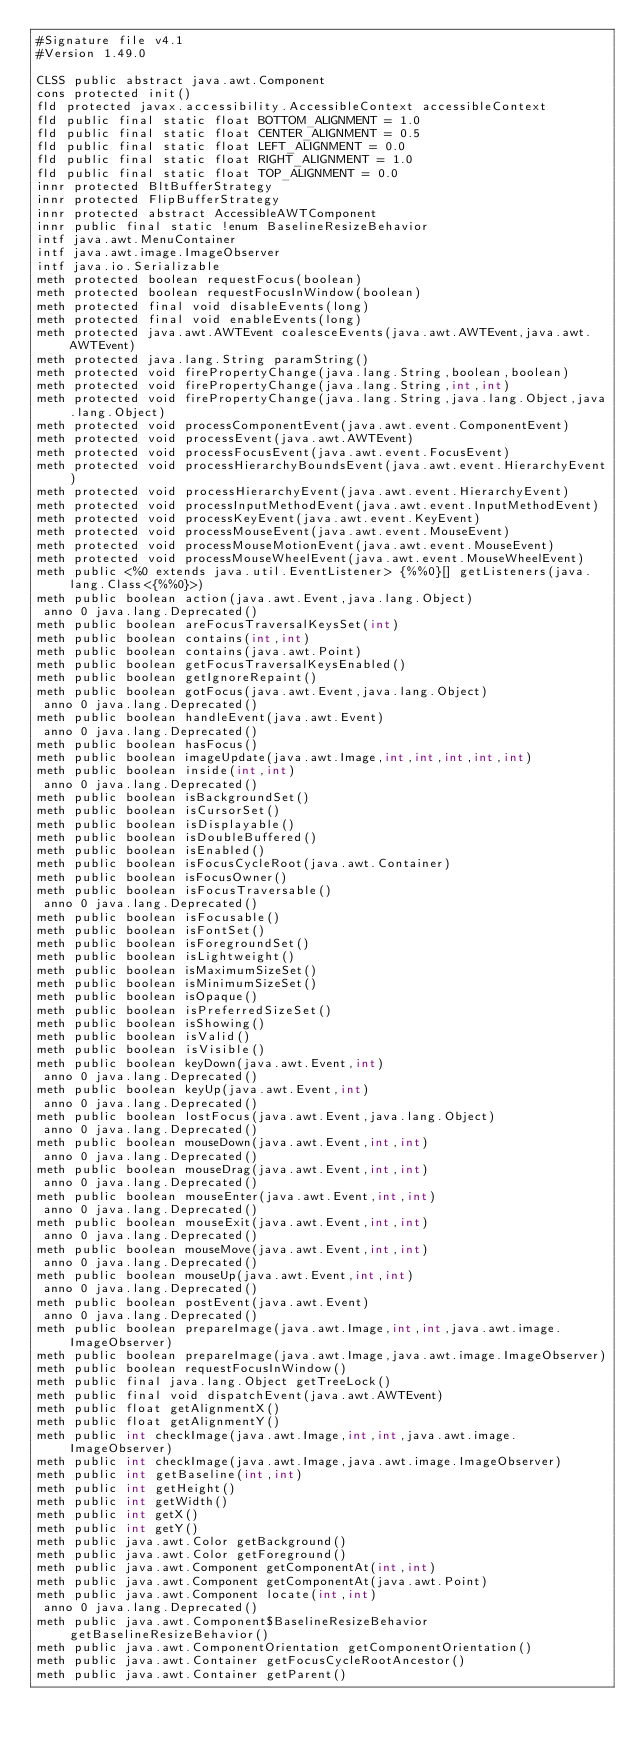<code> <loc_0><loc_0><loc_500><loc_500><_SML_>#Signature file v4.1
#Version 1.49.0

CLSS public abstract java.awt.Component
cons protected init()
fld protected javax.accessibility.AccessibleContext accessibleContext
fld public final static float BOTTOM_ALIGNMENT = 1.0
fld public final static float CENTER_ALIGNMENT = 0.5
fld public final static float LEFT_ALIGNMENT = 0.0
fld public final static float RIGHT_ALIGNMENT = 1.0
fld public final static float TOP_ALIGNMENT = 0.0
innr protected BltBufferStrategy
innr protected FlipBufferStrategy
innr protected abstract AccessibleAWTComponent
innr public final static !enum BaselineResizeBehavior
intf java.awt.MenuContainer
intf java.awt.image.ImageObserver
intf java.io.Serializable
meth protected boolean requestFocus(boolean)
meth protected boolean requestFocusInWindow(boolean)
meth protected final void disableEvents(long)
meth protected final void enableEvents(long)
meth protected java.awt.AWTEvent coalesceEvents(java.awt.AWTEvent,java.awt.AWTEvent)
meth protected java.lang.String paramString()
meth protected void firePropertyChange(java.lang.String,boolean,boolean)
meth protected void firePropertyChange(java.lang.String,int,int)
meth protected void firePropertyChange(java.lang.String,java.lang.Object,java.lang.Object)
meth protected void processComponentEvent(java.awt.event.ComponentEvent)
meth protected void processEvent(java.awt.AWTEvent)
meth protected void processFocusEvent(java.awt.event.FocusEvent)
meth protected void processHierarchyBoundsEvent(java.awt.event.HierarchyEvent)
meth protected void processHierarchyEvent(java.awt.event.HierarchyEvent)
meth protected void processInputMethodEvent(java.awt.event.InputMethodEvent)
meth protected void processKeyEvent(java.awt.event.KeyEvent)
meth protected void processMouseEvent(java.awt.event.MouseEvent)
meth protected void processMouseMotionEvent(java.awt.event.MouseEvent)
meth protected void processMouseWheelEvent(java.awt.event.MouseWheelEvent)
meth public <%0 extends java.util.EventListener> {%%0}[] getListeners(java.lang.Class<{%%0}>)
meth public boolean action(java.awt.Event,java.lang.Object)
 anno 0 java.lang.Deprecated()
meth public boolean areFocusTraversalKeysSet(int)
meth public boolean contains(int,int)
meth public boolean contains(java.awt.Point)
meth public boolean getFocusTraversalKeysEnabled()
meth public boolean getIgnoreRepaint()
meth public boolean gotFocus(java.awt.Event,java.lang.Object)
 anno 0 java.lang.Deprecated()
meth public boolean handleEvent(java.awt.Event)
 anno 0 java.lang.Deprecated()
meth public boolean hasFocus()
meth public boolean imageUpdate(java.awt.Image,int,int,int,int,int)
meth public boolean inside(int,int)
 anno 0 java.lang.Deprecated()
meth public boolean isBackgroundSet()
meth public boolean isCursorSet()
meth public boolean isDisplayable()
meth public boolean isDoubleBuffered()
meth public boolean isEnabled()
meth public boolean isFocusCycleRoot(java.awt.Container)
meth public boolean isFocusOwner()
meth public boolean isFocusTraversable()
 anno 0 java.lang.Deprecated()
meth public boolean isFocusable()
meth public boolean isFontSet()
meth public boolean isForegroundSet()
meth public boolean isLightweight()
meth public boolean isMaximumSizeSet()
meth public boolean isMinimumSizeSet()
meth public boolean isOpaque()
meth public boolean isPreferredSizeSet()
meth public boolean isShowing()
meth public boolean isValid()
meth public boolean isVisible()
meth public boolean keyDown(java.awt.Event,int)
 anno 0 java.lang.Deprecated()
meth public boolean keyUp(java.awt.Event,int)
 anno 0 java.lang.Deprecated()
meth public boolean lostFocus(java.awt.Event,java.lang.Object)
 anno 0 java.lang.Deprecated()
meth public boolean mouseDown(java.awt.Event,int,int)
 anno 0 java.lang.Deprecated()
meth public boolean mouseDrag(java.awt.Event,int,int)
 anno 0 java.lang.Deprecated()
meth public boolean mouseEnter(java.awt.Event,int,int)
 anno 0 java.lang.Deprecated()
meth public boolean mouseExit(java.awt.Event,int,int)
 anno 0 java.lang.Deprecated()
meth public boolean mouseMove(java.awt.Event,int,int)
 anno 0 java.lang.Deprecated()
meth public boolean mouseUp(java.awt.Event,int,int)
 anno 0 java.lang.Deprecated()
meth public boolean postEvent(java.awt.Event)
 anno 0 java.lang.Deprecated()
meth public boolean prepareImage(java.awt.Image,int,int,java.awt.image.ImageObserver)
meth public boolean prepareImage(java.awt.Image,java.awt.image.ImageObserver)
meth public boolean requestFocusInWindow()
meth public final java.lang.Object getTreeLock()
meth public final void dispatchEvent(java.awt.AWTEvent)
meth public float getAlignmentX()
meth public float getAlignmentY()
meth public int checkImage(java.awt.Image,int,int,java.awt.image.ImageObserver)
meth public int checkImage(java.awt.Image,java.awt.image.ImageObserver)
meth public int getBaseline(int,int)
meth public int getHeight()
meth public int getWidth()
meth public int getX()
meth public int getY()
meth public java.awt.Color getBackground()
meth public java.awt.Color getForeground()
meth public java.awt.Component getComponentAt(int,int)
meth public java.awt.Component getComponentAt(java.awt.Point)
meth public java.awt.Component locate(int,int)
 anno 0 java.lang.Deprecated()
meth public java.awt.Component$BaselineResizeBehavior getBaselineResizeBehavior()
meth public java.awt.ComponentOrientation getComponentOrientation()
meth public java.awt.Container getFocusCycleRootAncestor()
meth public java.awt.Container getParent()</code> 